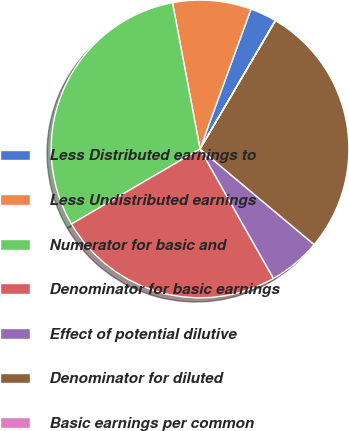<chart> <loc_0><loc_0><loc_500><loc_500><pie_chart><fcel>Less Distributed earnings to<fcel>Less Undistributed earnings<fcel>Numerator for basic and<fcel>Denominator for basic earnings<fcel>Effect of potential dilutive<fcel>Denominator for diluted<fcel>Basic earnings per common<nl><fcel>2.87%<fcel>8.52%<fcel>30.45%<fcel>24.8%<fcel>5.69%<fcel>27.63%<fcel>0.04%<nl></chart> 